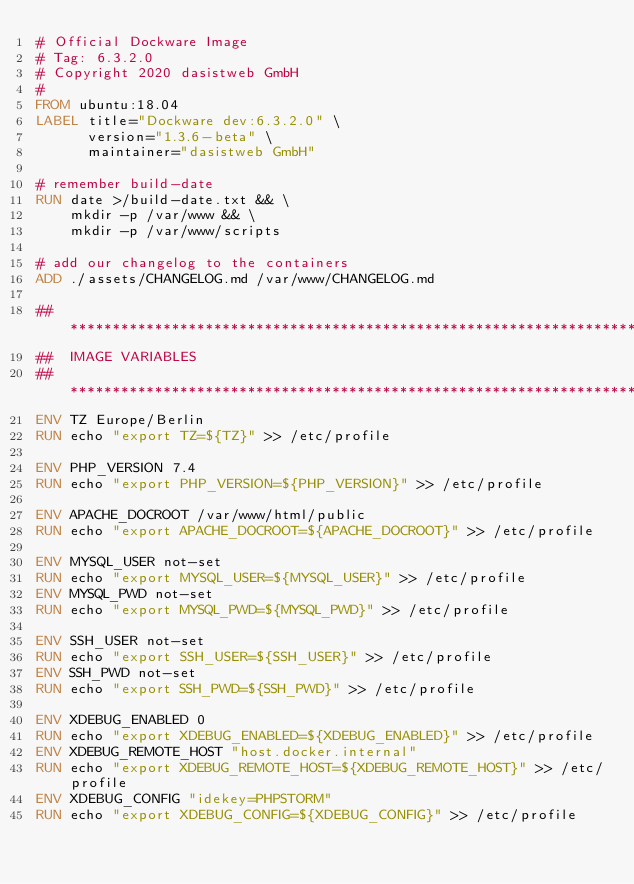<code> <loc_0><loc_0><loc_500><loc_500><_Dockerfile_># Official Dockware Image
# Tag: 6.3.2.0
# Copyright 2020 dasistweb GmbH
#
FROM ubuntu:18.04
LABEL title="Dockware dev:6.3.2.0" \
      version="1.3.6-beta" \
      maintainer="dasistweb GmbH"

# remember build-date
RUN date >/build-date.txt && \
    mkdir -p /var/www && \
    mkdir -p /var/www/scripts

# add our changelog to the containers
ADD ./assets/CHANGELOG.md /var/www/CHANGELOG.md

## ***********************************************************************
##  IMAGE VARIABLES
## ***********************************************************************
ENV TZ Europe/Berlin
RUN echo "export TZ=${TZ}" >> /etc/profile

ENV PHP_VERSION 7.4
RUN echo "export PHP_VERSION=${PHP_VERSION}" >> /etc/profile

ENV APACHE_DOCROOT /var/www/html/public
RUN echo "export APACHE_DOCROOT=${APACHE_DOCROOT}" >> /etc/profile

ENV MYSQL_USER not-set
RUN echo "export MYSQL_USER=${MYSQL_USER}" >> /etc/profile
ENV MYSQL_PWD not-set
RUN echo "export MYSQL_PWD=${MYSQL_PWD}" >> /etc/profile

ENV SSH_USER not-set
RUN echo "export SSH_USER=${SSH_USER}" >> /etc/profile
ENV SSH_PWD not-set
RUN echo "export SSH_PWD=${SSH_PWD}" >> /etc/profile

ENV XDEBUG_ENABLED 0
RUN echo "export XDEBUG_ENABLED=${XDEBUG_ENABLED}" >> /etc/profile
ENV XDEBUG_REMOTE_HOST "host.docker.internal"
RUN echo "export XDEBUG_REMOTE_HOST=${XDEBUG_REMOTE_HOST}" >> /etc/profile
ENV XDEBUG_CONFIG "idekey=PHPSTORM"
RUN echo "export XDEBUG_CONFIG=${XDEBUG_CONFIG}" >> /etc/profile</code> 